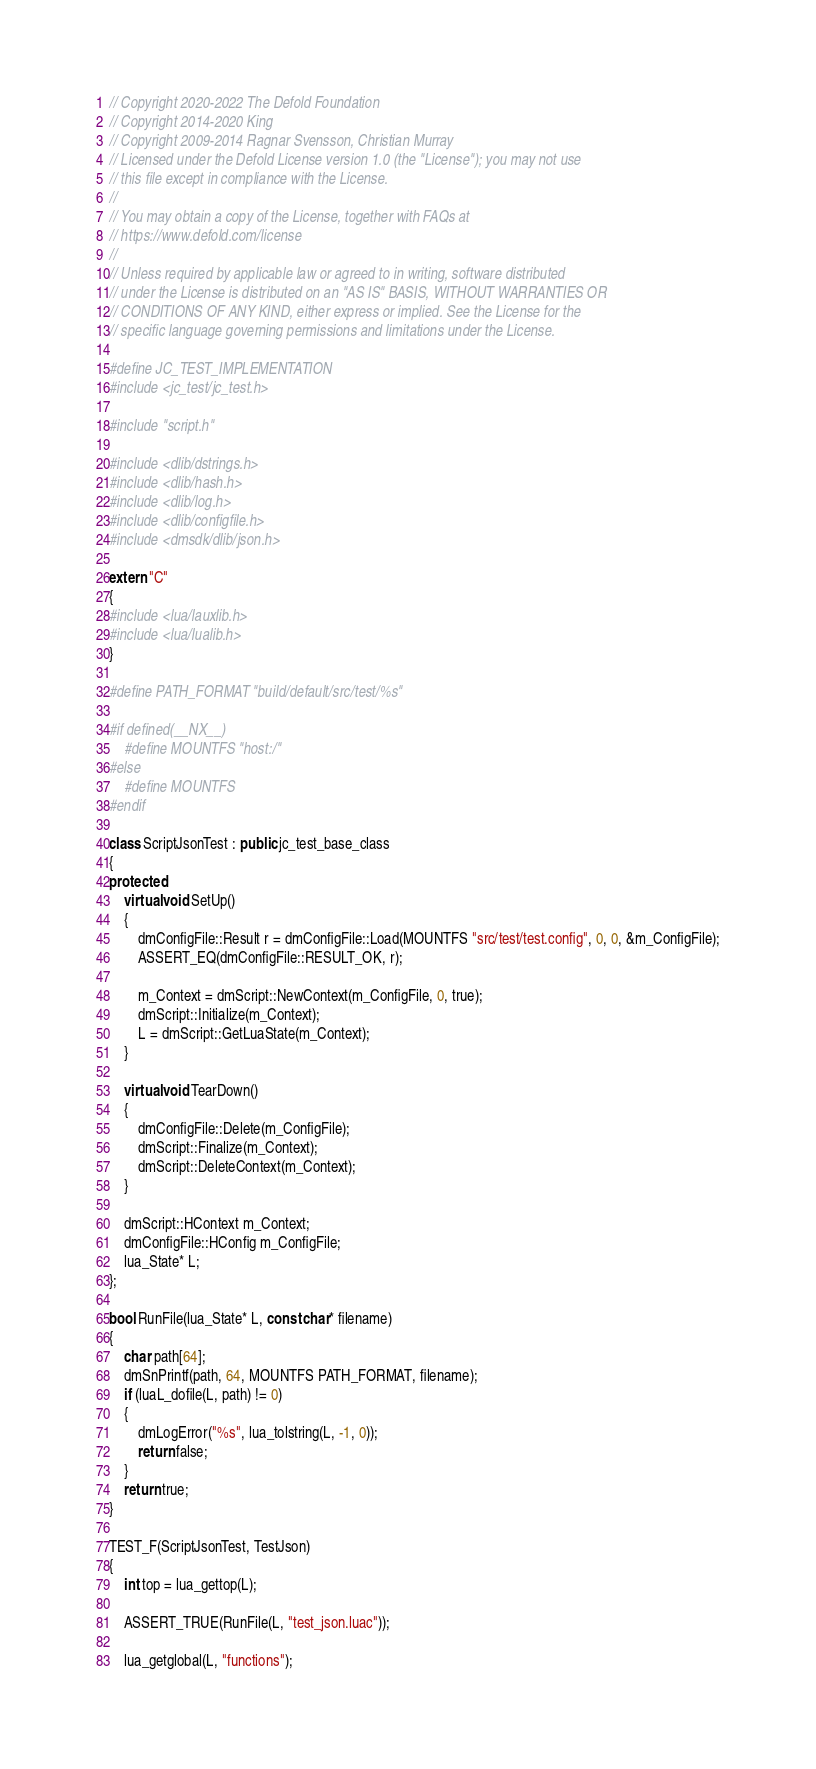Convert code to text. <code><loc_0><loc_0><loc_500><loc_500><_C++_>// Copyright 2020-2022 The Defold Foundation
// Copyright 2014-2020 King
// Copyright 2009-2014 Ragnar Svensson, Christian Murray
// Licensed under the Defold License version 1.0 (the "License"); you may not use
// this file except in compliance with the License.
// 
// You may obtain a copy of the License, together with FAQs at
// https://www.defold.com/license
// 
// Unless required by applicable law or agreed to in writing, software distributed
// under the License is distributed on an "AS IS" BASIS, WITHOUT WARRANTIES OR
// CONDITIONS OF ANY KIND, either express or implied. See the License for the
// specific language governing permissions and limitations under the License.

#define JC_TEST_IMPLEMENTATION
#include <jc_test/jc_test.h>

#include "script.h"

#include <dlib/dstrings.h>
#include <dlib/hash.h>
#include <dlib/log.h>
#include <dlib/configfile.h>
#include <dmsdk/dlib/json.h>

extern "C"
{
#include <lua/lauxlib.h>
#include <lua/lualib.h>
}

#define PATH_FORMAT "build/default/src/test/%s"

#if defined(__NX__)
    #define MOUNTFS "host:/"
#else
    #define MOUNTFS
#endif

class ScriptJsonTest : public jc_test_base_class
{
protected:
    virtual void SetUp()
    {
        dmConfigFile::Result r = dmConfigFile::Load(MOUNTFS "src/test/test.config", 0, 0, &m_ConfigFile);
        ASSERT_EQ(dmConfigFile::RESULT_OK, r);

        m_Context = dmScript::NewContext(m_ConfigFile, 0, true);
        dmScript::Initialize(m_Context);
        L = dmScript::GetLuaState(m_Context);
    }

    virtual void TearDown()
    {
        dmConfigFile::Delete(m_ConfigFile);
        dmScript::Finalize(m_Context);
        dmScript::DeleteContext(m_Context);
    }

    dmScript::HContext m_Context;
    dmConfigFile::HConfig m_ConfigFile;
    lua_State* L;
};

bool RunFile(lua_State* L, const char* filename)
{
    char path[64];
    dmSnPrintf(path, 64, MOUNTFS PATH_FORMAT, filename);
    if (luaL_dofile(L, path) != 0)
    {
        dmLogError("%s", lua_tolstring(L, -1, 0));
        return false;
    }
    return true;
}

TEST_F(ScriptJsonTest, TestJson)
{
    int top = lua_gettop(L);

    ASSERT_TRUE(RunFile(L, "test_json.luac"));

    lua_getglobal(L, "functions");</code> 